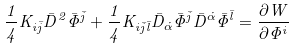Convert formula to latex. <formula><loc_0><loc_0><loc_500><loc_500>\frac { 1 } { 4 } K _ { i \bar { j } } \bar { D } ^ { 2 } \bar { \Phi } ^ { \bar { j } } + \frac { 1 } { 4 } K _ { i \bar { j } \bar { l } } \bar { D } _ { \dot { \alpha } } \bar { \Phi } ^ { \bar { j } } \bar { D } ^ { \dot { \alpha } } \bar { \Phi } ^ { \bar { l } } = \frac { \partial W } { \partial \Phi ^ { i } }</formula> 